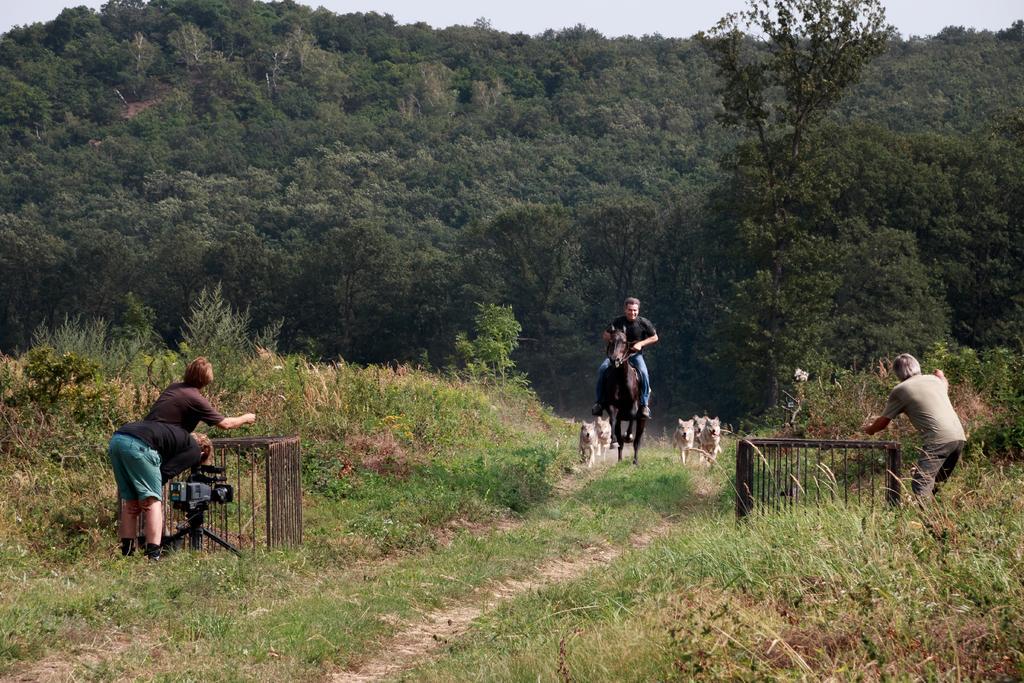Please provide a concise description of this image. In the picture I can see a two persons standing on the left side of the image, I can see video camera, cages, a person standing on the right side of the image. Here I can see a person sitting on the horse and riding and I can see few more animals are walking on the grassland. In the background, I can see trees and the sky. 